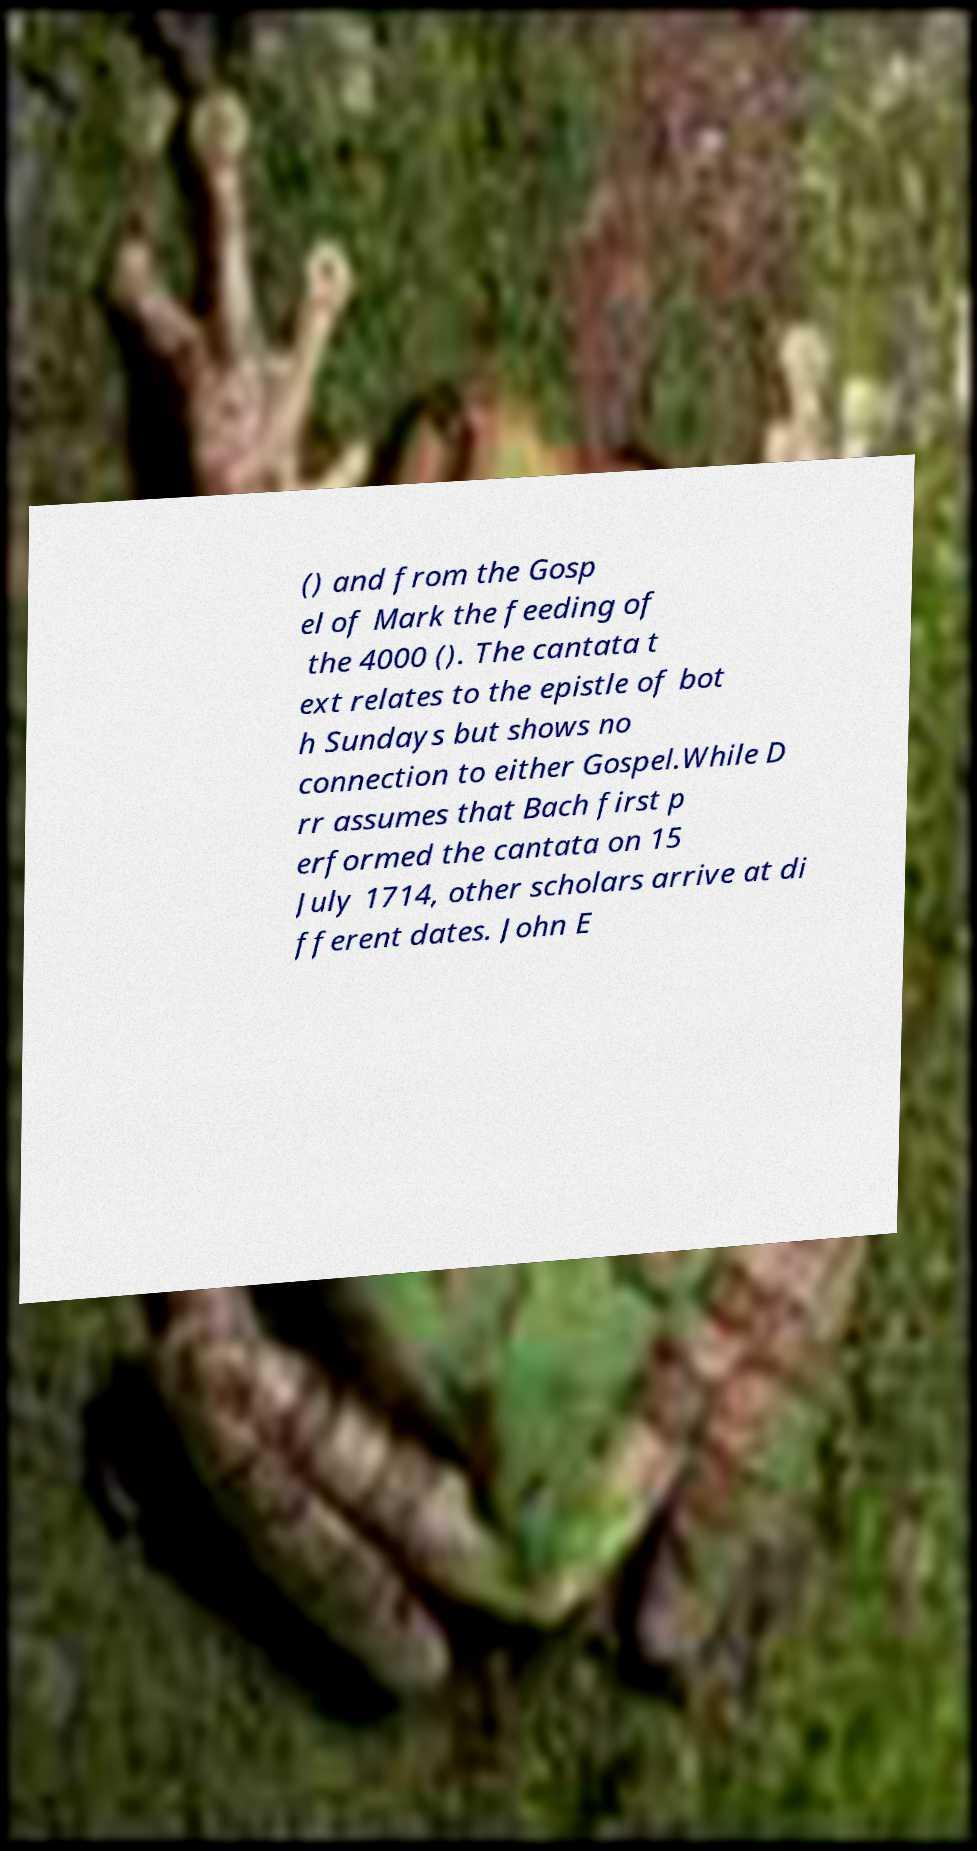What messages or text are displayed in this image? I need them in a readable, typed format. () and from the Gosp el of Mark the feeding of the 4000 (). The cantata t ext relates to the epistle of bot h Sundays but shows no connection to either Gospel.While D rr assumes that Bach first p erformed the cantata on 15 July 1714, other scholars arrive at di fferent dates. John E 